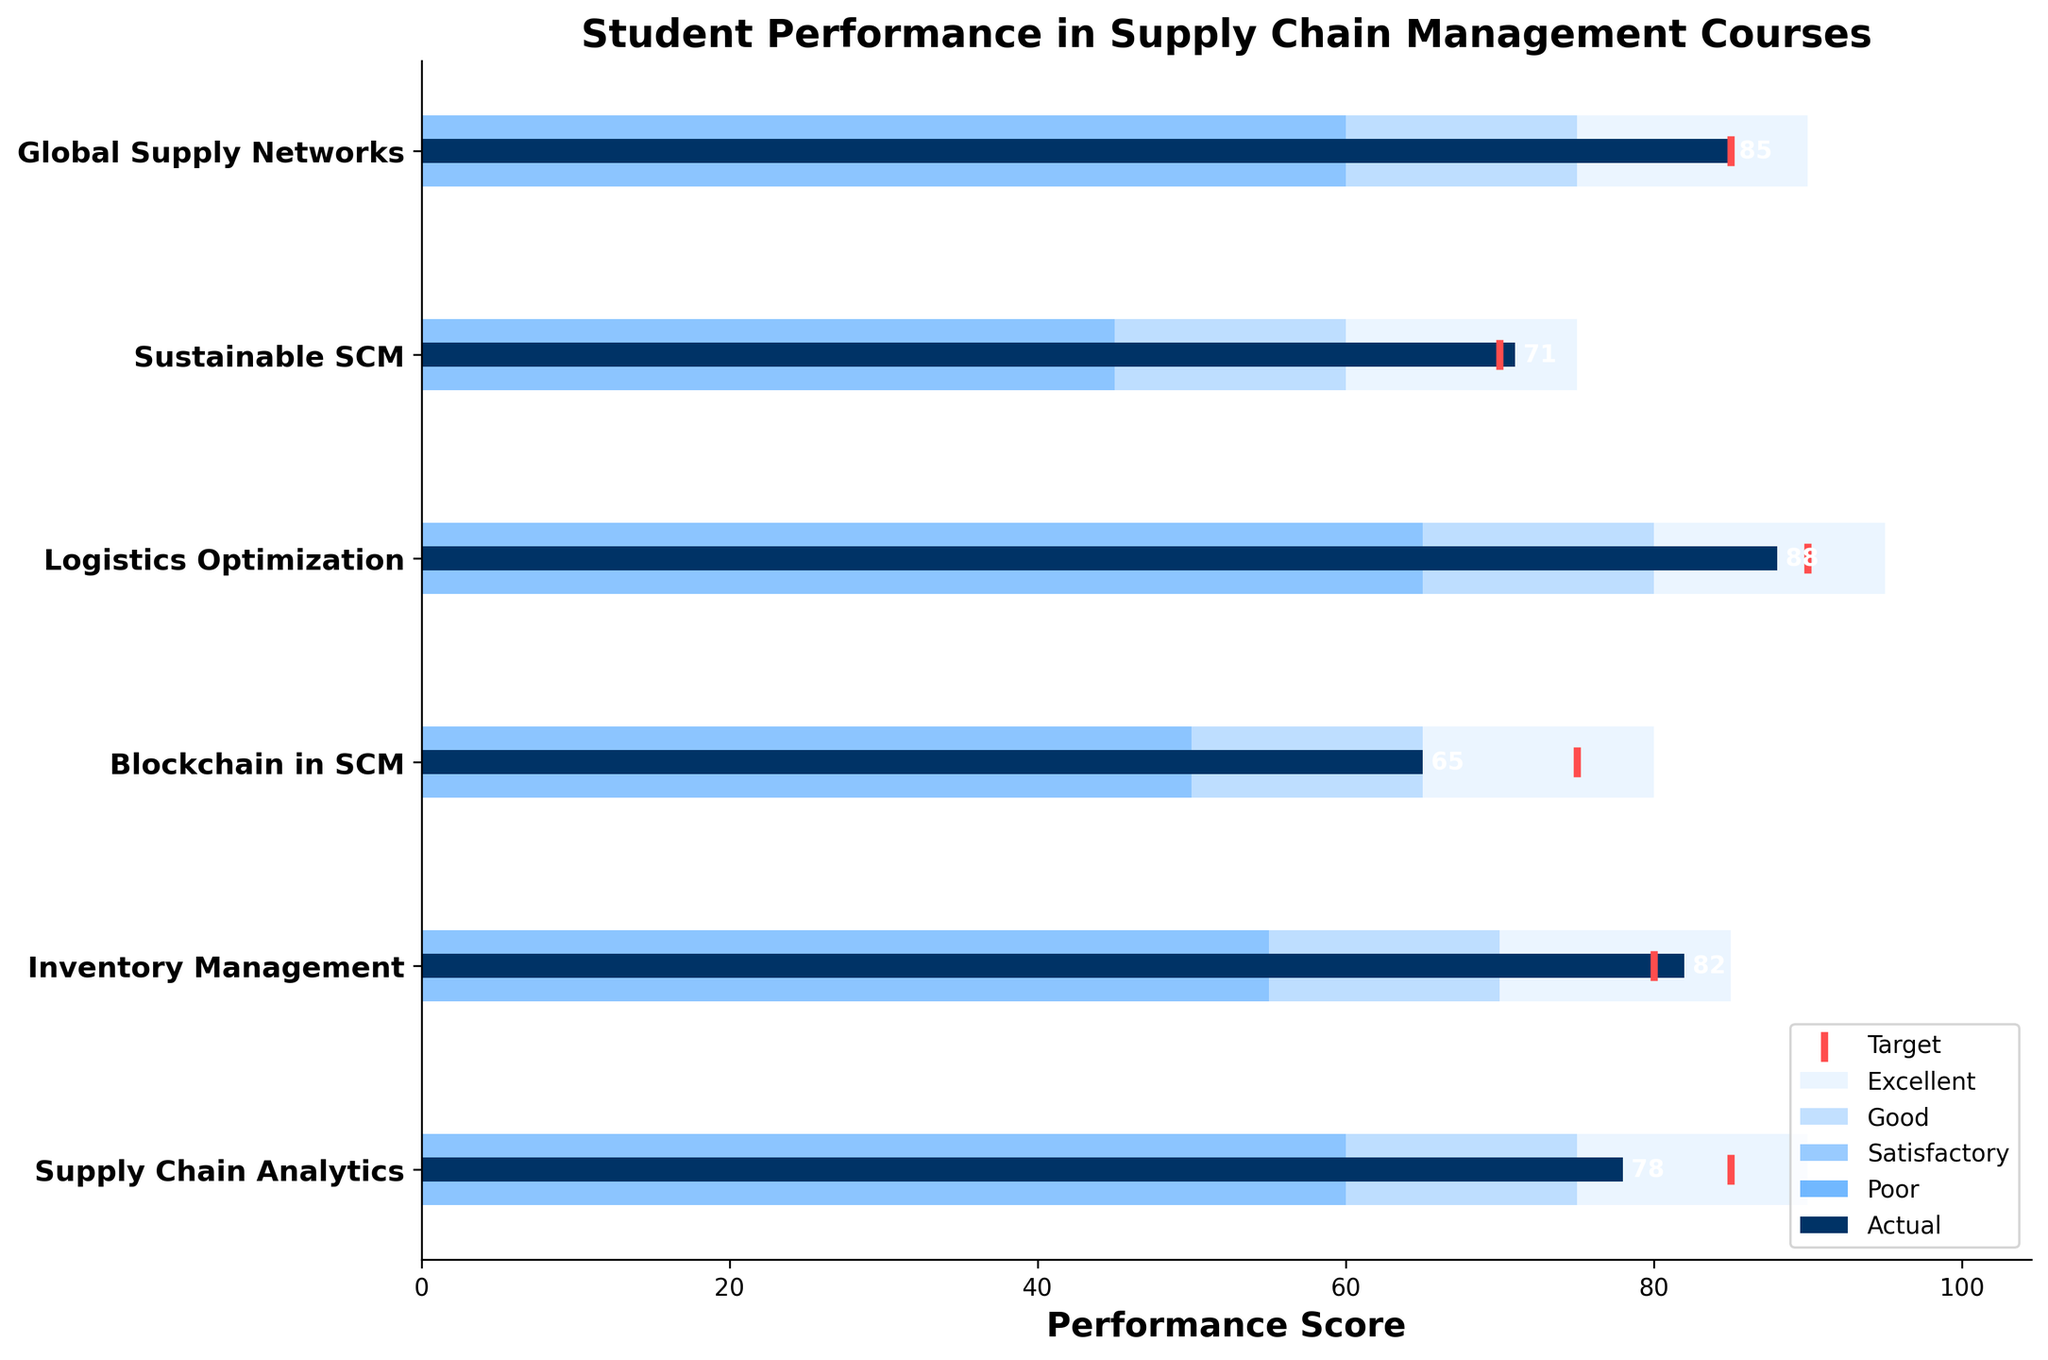What is the title of the figure? The title of the figure is located at the top of the chart and is usually the largest text.
Answer: Student Performance in Supply Chain Management Courses Which course has the highest actual performance score? The actual performance scores are represented by the blue bars in the chart. The course with the longest blue bar corresponds to the highest actual performance score.
Answer: Logistics Optimization What are the target scores for the courses? The target scores are represented by the red markers on the chart. By looking at the position of these markers for each course, we can identify the target scores.
Answer: [85, 80, 75, 90, 70, 85] Which courses did not meet their target scores? To determine which courses did not meet their target scores, compare the actual performance scores (blue bars) with the target scores (red markers). If the blue bar is shorter than the red marker, the target was not met.
Answer: Supply Chain Analytics, Blockchain in SCM, Logistics Optimization How does the performance in "Blockchain in SCM" compare to its target? Look at the blue bar for "Blockchain in SCM" and compare it with its red target marker. The actual performance score (65) is below the target score (75).
Answer: Below target by 10 points What is the average actual performance score across all courses? To find the average, sum all actual performance scores and divide by the number of courses, (78 + 82 + 65 + 88 + 71 + 85) / 6.
Answer: 78.17 Which course has the smallest difference between its actual and target scores? Calculate the difference between the actual and target scores for each course, and identify the smallest difference. The differences are [7, 2, 10, 2, -1, 0].
Answer: Global Supply Networks In which performance category does "Sustainable SCM" fall? Look at the different colored ranges behind the blue bar for "Sustainable SCM" and see where the bar ends. The performance score (71) falls in the "Satisfactory" range (45 to 60, 60 to 75).
Answer: Satisfactory How many courses have an actual performance score in the "Good" or "Excellent" range? Identify the courses where the actual performance score (blue bar) falls within the ranges marked "Good" or "Excellent" (beyond 75 or 90).
Answer: Four courses (Supply Chain Analytics, Inventory Management, Logistics Optimization, Global Supply Networks) By how many points does the actual performance score of "Supply Chain Analytics" fall short of the "Excellent" threshold? The "Excellent" threshold for "Supply Chain Analytics" is 90, while the actual score is 78. Subtract 78 from 90 to determine the shortfall.
Answer: 12 